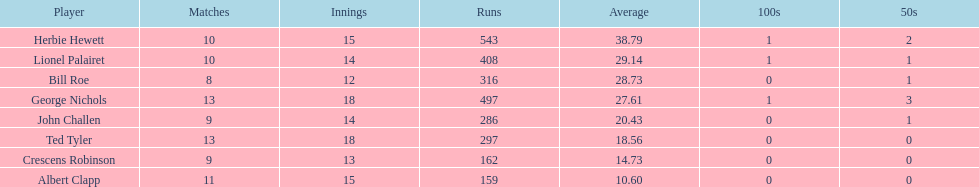What is the lowest amount of runs anyone possesses? 159. 